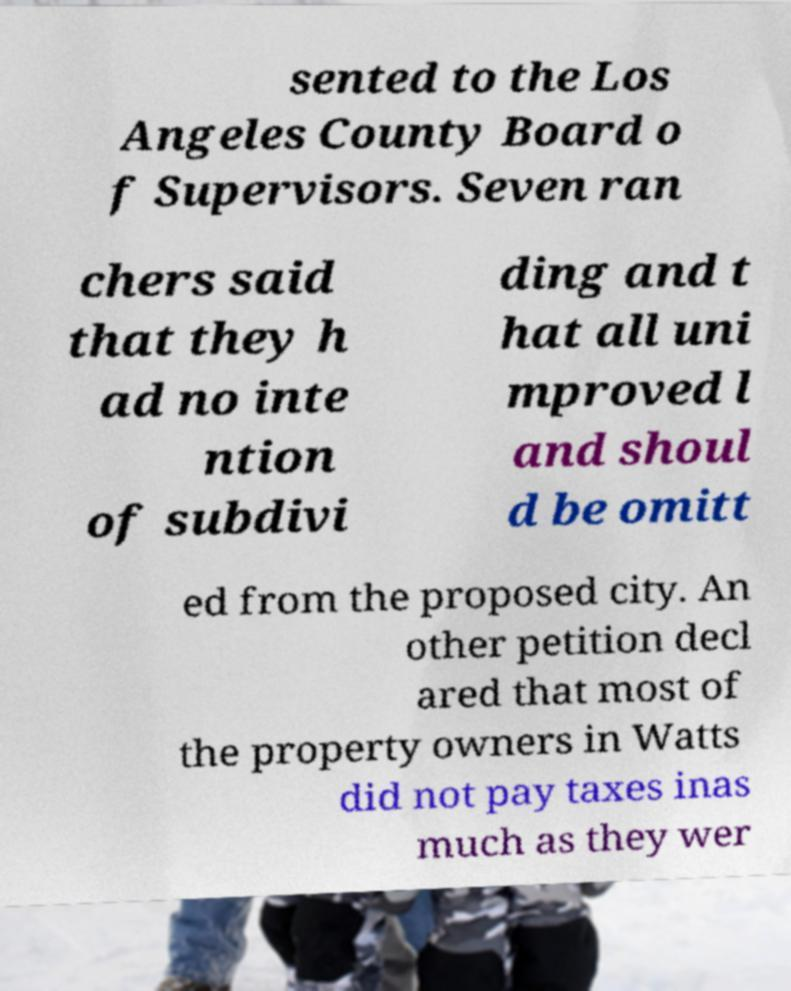For documentation purposes, I need the text within this image transcribed. Could you provide that? sented to the Los Angeles County Board o f Supervisors. Seven ran chers said that they h ad no inte ntion of subdivi ding and t hat all uni mproved l and shoul d be omitt ed from the proposed city. An other petition decl ared that most of the property owners in Watts did not pay taxes inas much as they wer 